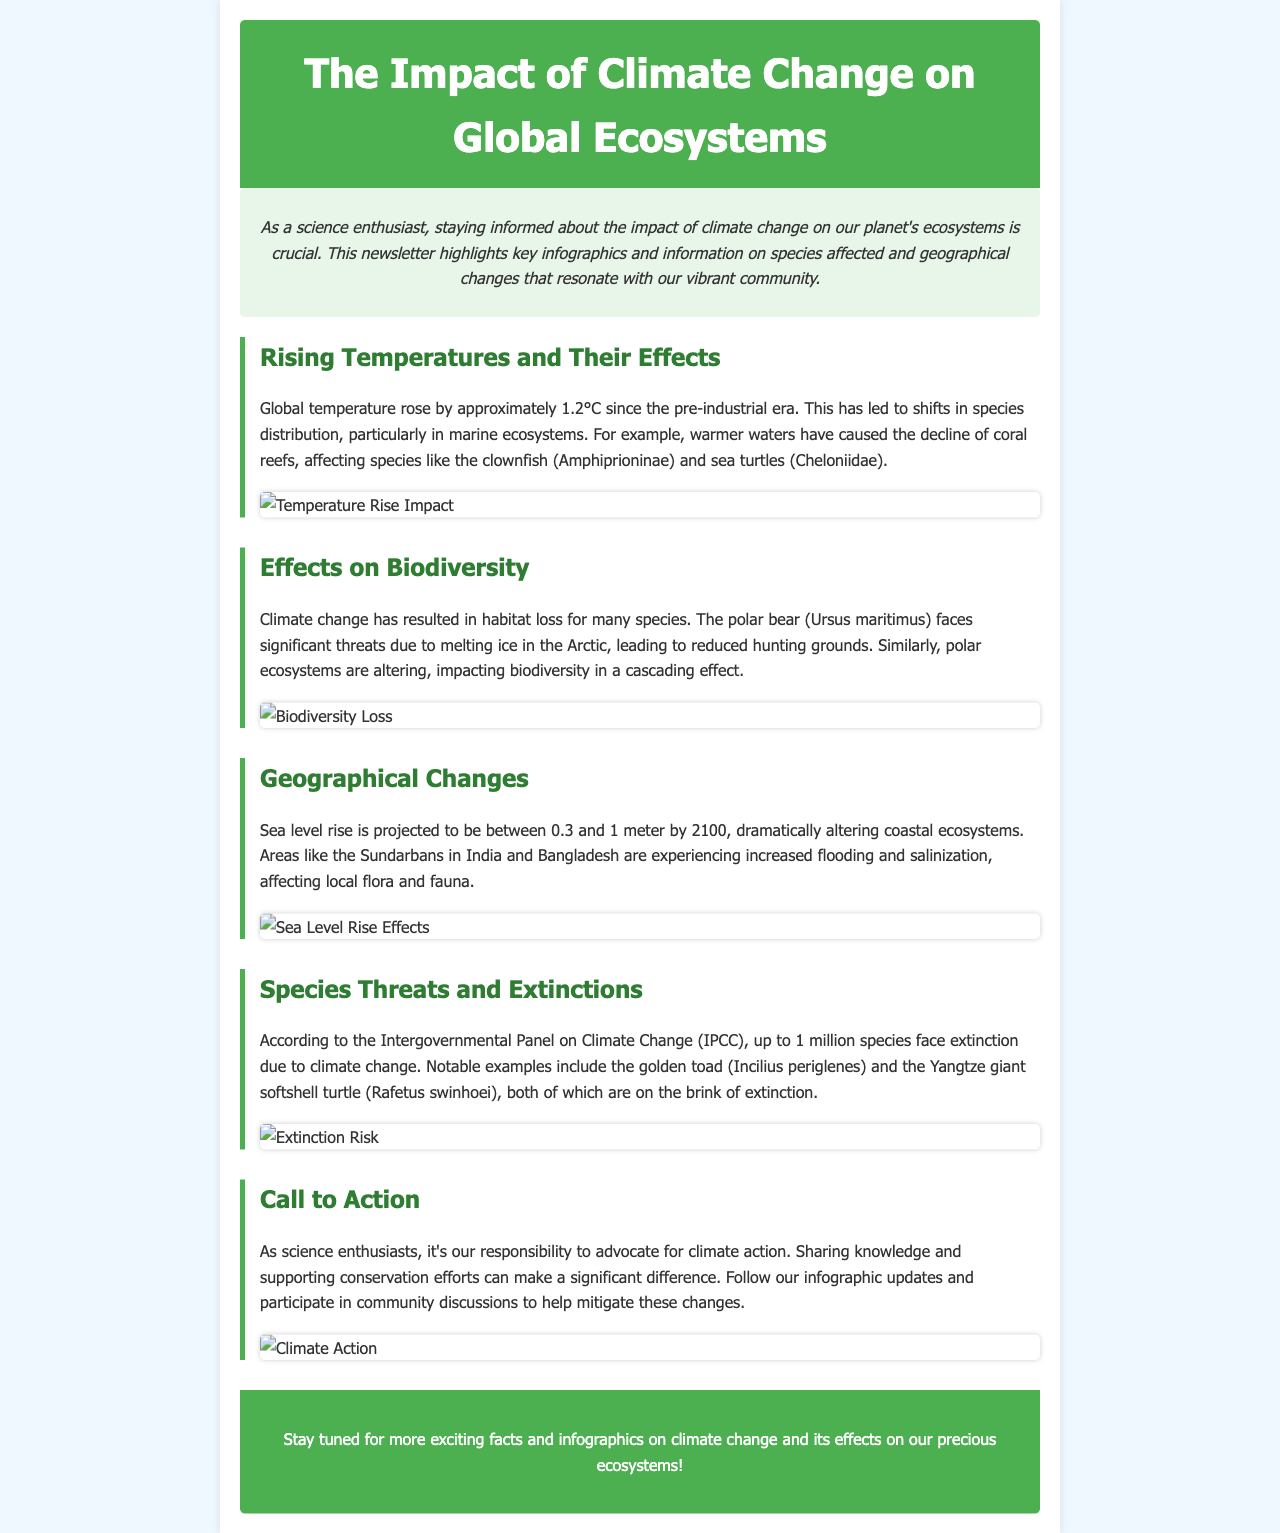What is the increase in global temperature since the pre-industrial era? The increase in global temperature is stated as approximately 1.2°C since the pre-industrial era.
Answer: 1.2°C Which species is affected by the decline of coral reefs? The document mentions that the clownfish (Amphiprioninae) is one of the species affected by the decline of coral reefs.
Answer: clownfish What is projected sea level rise by 2100? The document states that the projected sea level rise is between 0.3 and 1 meter by 2100.
Answer: 0.3 to 1 meter Which turtle species is on the brink of extinction? The Yangtze giant softshell turtle (Rafetus swinhoei) is mentioned as being on the brink of extinction.
Answer: Yangtze giant softshell turtle What does the document suggest as a call to action? The document encourages readers to advocate for climate action and support conservation efforts, emphasizing sharing knowledge and participating in discussions.
Answer: advocate for climate action What impact does climate change have on polar bear hunting grounds? Climate change leads to melting ice in the Arctic, which reduces hunting grounds for polar bears (Ursus maritimus).
Answer: reduced hunting grounds Which geographical area is experiencing increased flooding due to sea level rise? The document specifies that the Sundarbans in India and Bangladesh are experiencing increased flooding due to sea level rise.
Answer: Sundarbans How many species face extinction due to climate change according to the IPCC? The document indicates that up to 1 million species face extinction due to climate change, according to the IPCC.
Answer: 1 million 